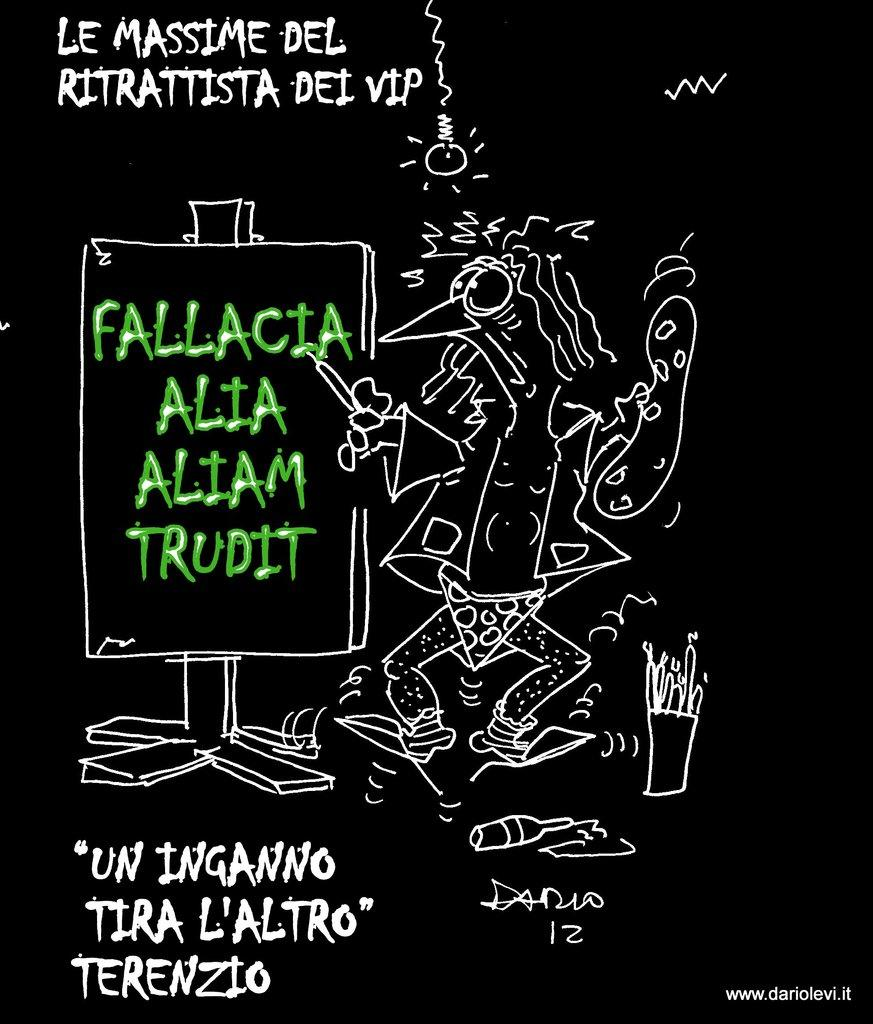<image>
Present a compact description of the photo's key features. Poster of a chicken in his underwear that has the website www.dariolevi.it. 